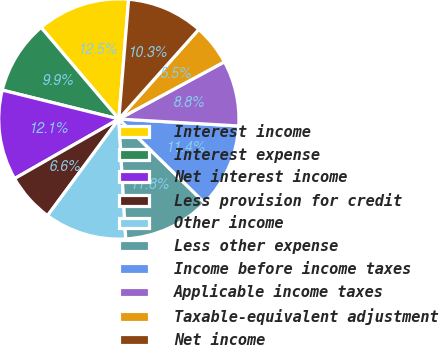Convert chart to OTSL. <chart><loc_0><loc_0><loc_500><loc_500><pie_chart><fcel>Interest income<fcel>Interest expense<fcel>Net interest income<fcel>Less provision for credit<fcel>Other income<fcel>Less other expense<fcel>Income before income taxes<fcel>Applicable income taxes<fcel>Taxable-equivalent adjustment<fcel>Net income<nl><fcel>12.5%<fcel>9.93%<fcel>12.13%<fcel>6.62%<fcel>11.03%<fcel>11.76%<fcel>11.4%<fcel>8.82%<fcel>5.51%<fcel>10.29%<nl></chart> 